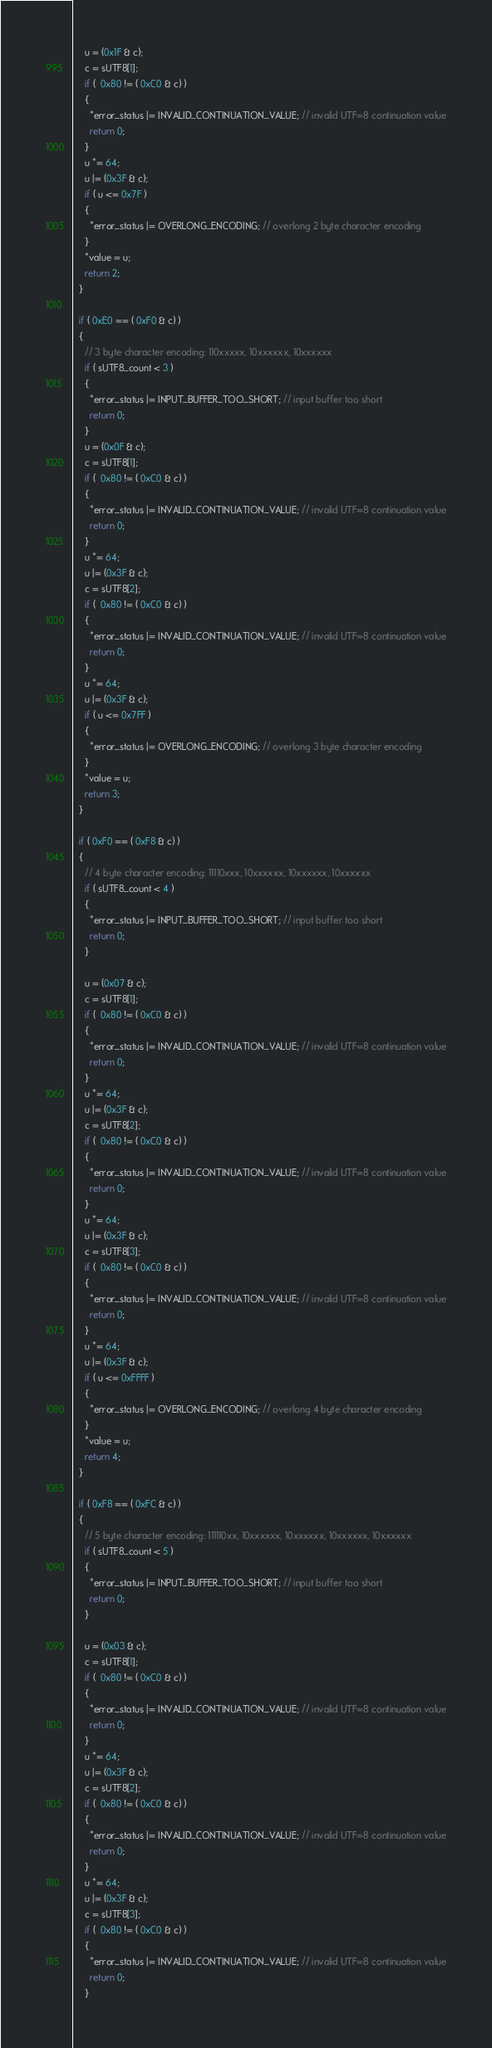<code> <loc_0><loc_0><loc_500><loc_500><_C++_>    u = (0x1F & c);
    c = sUTF8[1];
    if (  0x80 != ( 0xC0 & c) )
    {
      *error_status |= INVALID_CONTINUATION_VALUE; // invalid UTF=8 continuation value
      return 0;
    }
    u *= 64;
    u |= (0x3F & c);
    if ( u <= 0x7F )
    {
      *error_status |= OVERLONG_ENCODING; // overlong 2 byte character encoding
    }
    *value = u;
    return 2;
  }

  if ( 0xE0 == ( 0xF0 & c) )
  {
    // 3 byte character encoding: 110xxxxx, 10xxxxxx, 10xxxxxx
    if ( sUTF8_count < 3 )
    {
      *error_status |= INPUT_BUFFER_TOO_SHORT; // input buffer too short
      return 0;
    }
    u = (0x0F & c);
    c = sUTF8[1];
    if (  0x80 != ( 0xC0 & c) )
    {
      *error_status |= INVALID_CONTINUATION_VALUE; // invalid UTF=8 continuation value
      return 0;
    }
    u *= 64;
    u |= (0x3F & c);
    c = sUTF8[2];
    if (  0x80 != ( 0xC0 & c) )
    {
      *error_status |= INVALID_CONTINUATION_VALUE; // invalid UTF=8 continuation value
      return 0;
    }
    u *= 64;
    u |= (0x3F & c);
    if ( u <= 0x7FF )
    {
      *error_status |= OVERLONG_ENCODING; // overlong 3 byte character encoding
    }
    *value = u;
    return 3;
  }

  if ( 0xF0 == ( 0xF8 & c) )
  {
    // 4 byte character encoding: 11110xxx, 10xxxxxx, 10xxxxxx, 10xxxxxx
    if ( sUTF8_count < 4 )
    {
      *error_status |= INPUT_BUFFER_TOO_SHORT; // input buffer too short
      return 0;
    }

    u = (0x07 & c);
    c = sUTF8[1];
    if (  0x80 != ( 0xC0 & c) )
    {
      *error_status |= INVALID_CONTINUATION_VALUE; // invalid UTF=8 continuation value
      return 0;
    }
    u *= 64;
    u |= (0x3F & c);
    c = sUTF8[2];
    if (  0x80 != ( 0xC0 & c) )
    {
      *error_status |= INVALID_CONTINUATION_VALUE; // invalid UTF=8 continuation value
      return 0;
    }
    u *= 64;
    u |= (0x3F & c);
    c = sUTF8[3];
    if (  0x80 != ( 0xC0 & c) )
    {
      *error_status |= INVALID_CONTINUATION_VALUE; // invalid UTF=8 continuation value
      return 0;
    }
    u *= 64;
    u |= (0x3F & c);
    if ( u <= 0xFFFF )
    {
      *error_status |= OVERLONG_ENCODING; // overlong 4 byte character encoding
    }
    *value = u;
    return 4;
  }
  
  if ( 0xF8 == ( 0xFC & c) )
  {
    // 5 byte character encoding: 111110xx, 10xxxxxx, 10xxxxxx, 10xxxxxx, 10xxxxxx
    if ( sUTF8_count < 5 )
    {
      *error_status |= INPUT_BUFFER_TOO_SHORT; // input buffer too short
      return 0;
    }

    u = (0x03 & c);
    c = sUTF8[1];
    if (  0x80 != ( 0xC0 & c) )
    {
      *error_status |= INVALID_CONTINUATION_VALUE; // invalid UTF=8 continuation value
      return 0;
    }
    u *= 64;
    u |= (0x3F & c);
    c = sUTF8[2];
    if (  0x80 != ( 0xC0 & c) )
    {
      *error_status |= INVALID_CONTINUATION_VALUE; // invalid UTF=8 continuation value
      return 0;
    }
    u *= 64;
    u |= (0x3F & c);
    c = sUTF8[3];
    if (  0x80 != ( 0xC0 & c) )
    {
      *error_status |= INVALID_CONTINUATION_VALUE; // invalid UTF=8 continuation value
      return 0;
    }</code> 